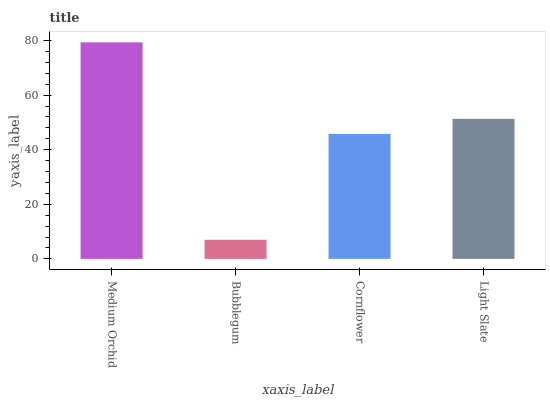Is Bubblegum the minimum?
Answer yes or no. Yes. Is Medium Orchid the maximum?
Answer yes or no. Yes. Is Cornflower the minimum?
Answer yes or no. No. Is Cornflower the maximum?
Answer yes or no. No. Is Cornflower greater than Bubblegum?
Answer yes or no. Yes. Is Bubblegum less than Cornflower?
Answer yes or no. Yes. Is Bubblegum greater than Cornflower?
Answer yes or no. No. Is Cornflower less than Bubblegum?
Answer yes or no. No. Is Light Slate the high median?
Answer yes or no. Yes. Is Cornflower the low median?
Answer yes or no. Yes. Is Medium Orchid the high median?
Answer yes or no. No. Is Medium Orchid the low median?
Answer yes or no. No. 